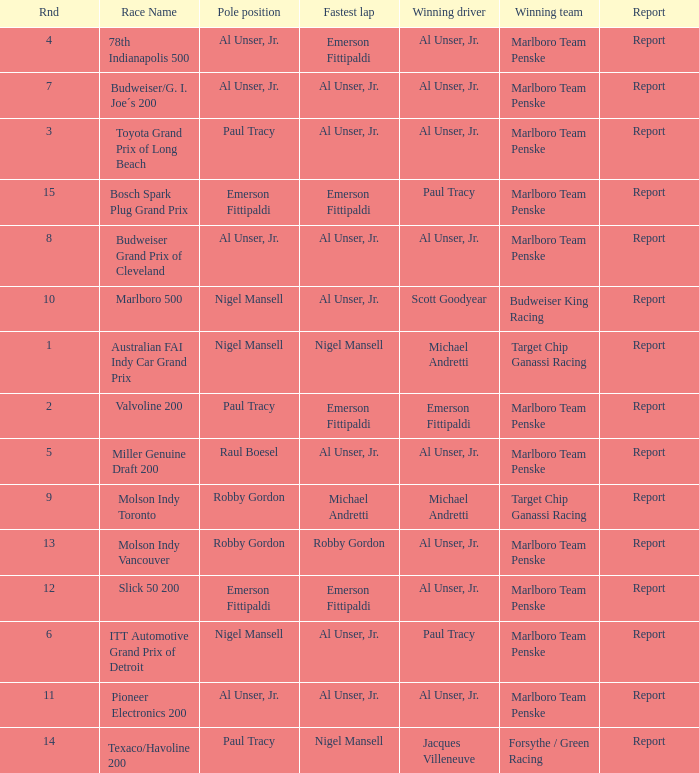What's the report of the race won by Michael Andretti, with Nigel Mansell driving the fastest lap? Report. 